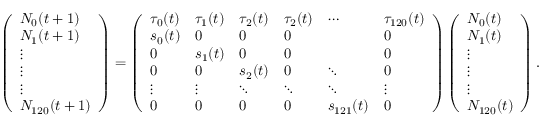<formula> <loc_0><loc_0><loc_500><loc_500>\left ( \begin{array} { l } { N _ { 0 } ( t + 1 ) } \\ { N _ { 1 } ( t + 1 ) } \\ { \vdots } \\ { \vdots } \\ { \vdots } \\ { N _ { 1 2 0 } ( t + 1 ) } \end{array} \right ) = \left ( \begin{array} { l l l l l l } { \tau _ { 0 } ( t ) } & { \tau _ { 1 } ( t ) } & { \tau _ { 2 } ( t ) } & { \tau _ { 2 } ( t ) } & { \cdots } & { \tau _ { 1 2 0 } ( t ) } \\ { s _ { 0 } ( t ) } & { 0 } & { 0 } & { 0 } & & { 0 } \\ { 0 } & { s _ { 1 } ( t ) } & { 0 } & { 0 } & & { 0 } \\ { 0 } & { 0 } & { s _ { 2 } ( t ) } & { 0 } & { \ddots } & { 0 } \\ { \vdots } & { \vdots } & { \ddots } & { \ddots } & { \ddots } & { \vdots } \\ { 0 } & { 0 } & { 0 } & { 0 } & { s _ { 1 2 1 } ( t ) } & { 0 } \end{array} \right ) \left ( \begin{array} { l } { N _ { 0 } ( t ) } \\ { N _ { 1 } ( t ) } \\ { \vdots } \\ { \vdots } \\ { \vdots } \\ { N _ { 1 2 0 } ( t ) } \end{array} \right ) .</formula> 